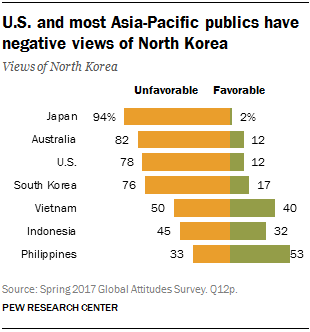Outline some significant characteristics in this image. A recent survey revealed that the country with the highest unfavorable negative views towards Korea is Japan. The unfavorable difference in the value of the US and South Korea is estimated to be approximately 2 trillion dollars. 